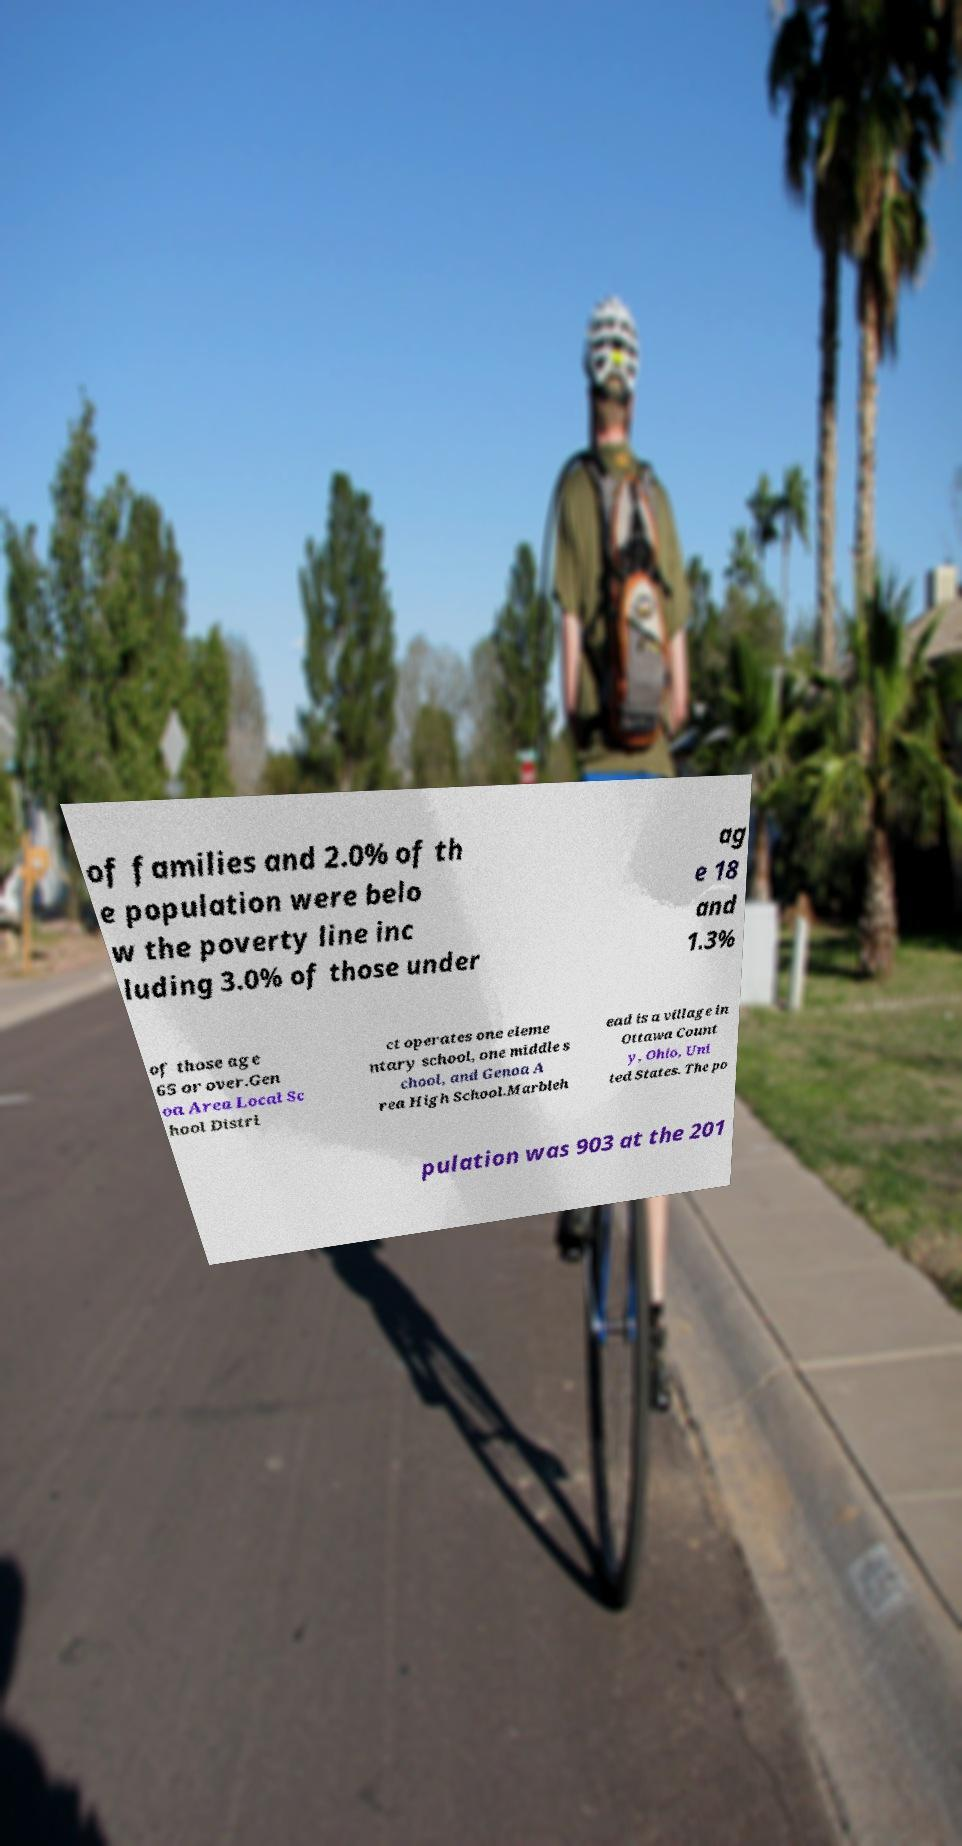Could you assist in decoding the text presented in this image and type it out clearly? of families and 2.0% of th e population were belo w the poverty line inc luding 3.0% of those under ag e 18 and 1.3% of those age 65 or over.Gen oa Area Local Sc hool Distri ct operates one eleme ntary school, one middle s chool, and Genoa A rea High School.Marbleh ead is a village in Ottawa Count y, Ohio, Uni ted States. The po pulation was 903 at the 201 